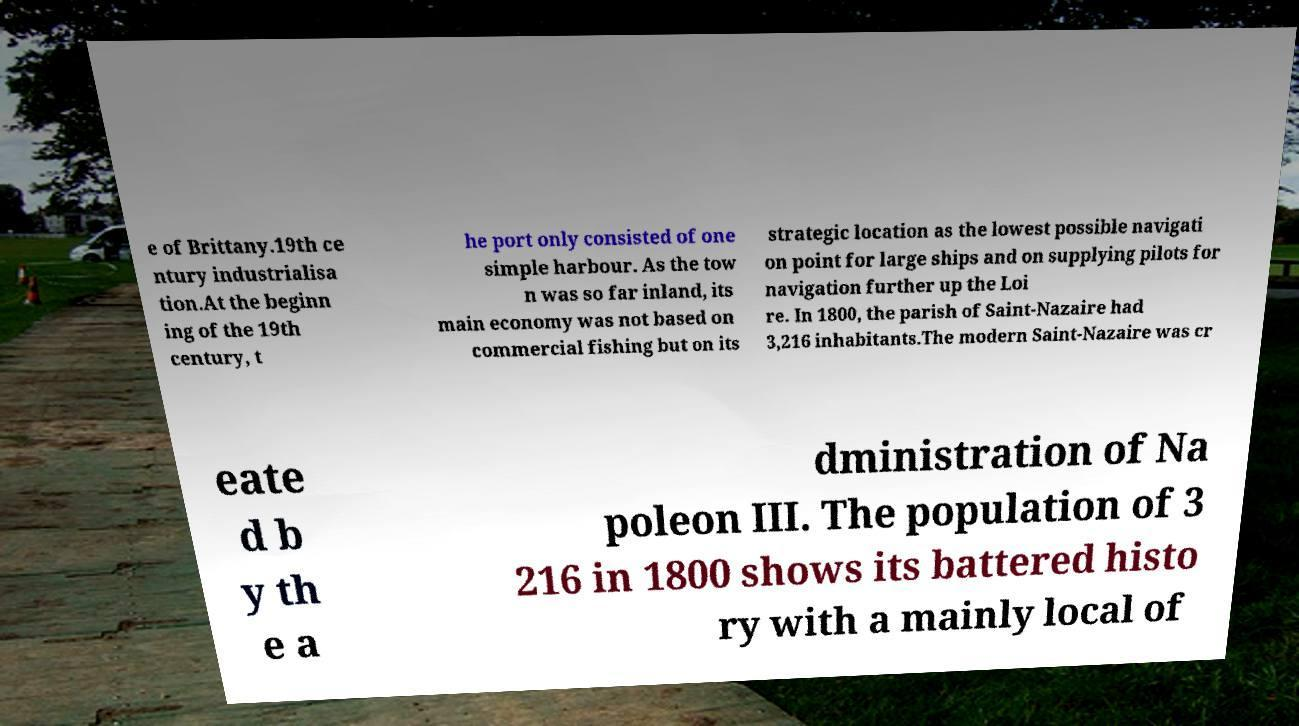Could you assist in decoding the text presented in this image and type it out clearly? e of Brittany.19th ce ntury industrialisa tion.At the beginn ing of the 19th century, t he port only consisted of one simple harbour. As the tow n was so far inland, its main economy was not based on commercial fishing but on its strategic location as the lowest possible navigati on point for large ships and on supplying pilots for navigation further up the Loi re. In 1800, the parish of Saint-Nazaire had 3,216 inhabitants.The modern Saint-Nazaire was cr eate d b y th e a dministration of Na poleon III. The population of 3 216 in 1800 shows its battered histo ry with a mainly local of 